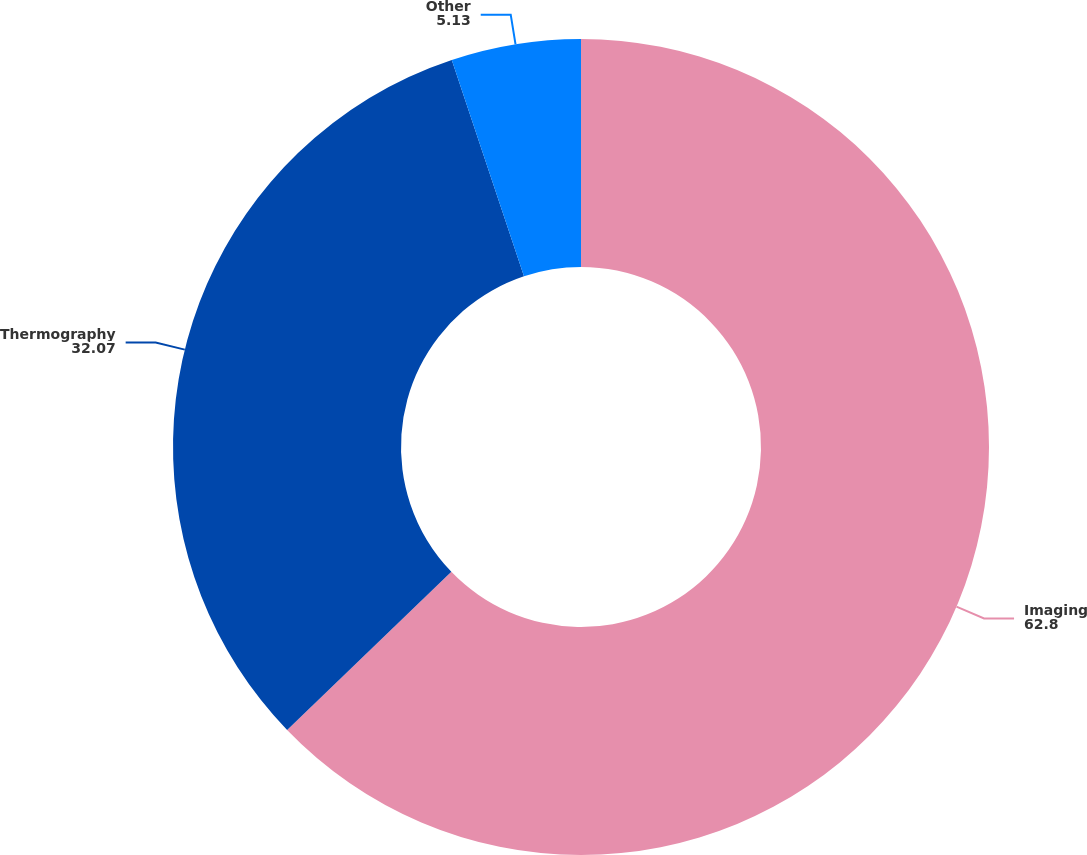Convert chart to OTSL. <chart><loc_0><loc_0><loc_500><loc_500><pie_chart><fcel>Imaging<fcel>Thermography<fcel>Other<nl><fcel>62.8%<fcel>32.07%<fcel>5.13%<nl></chart> 